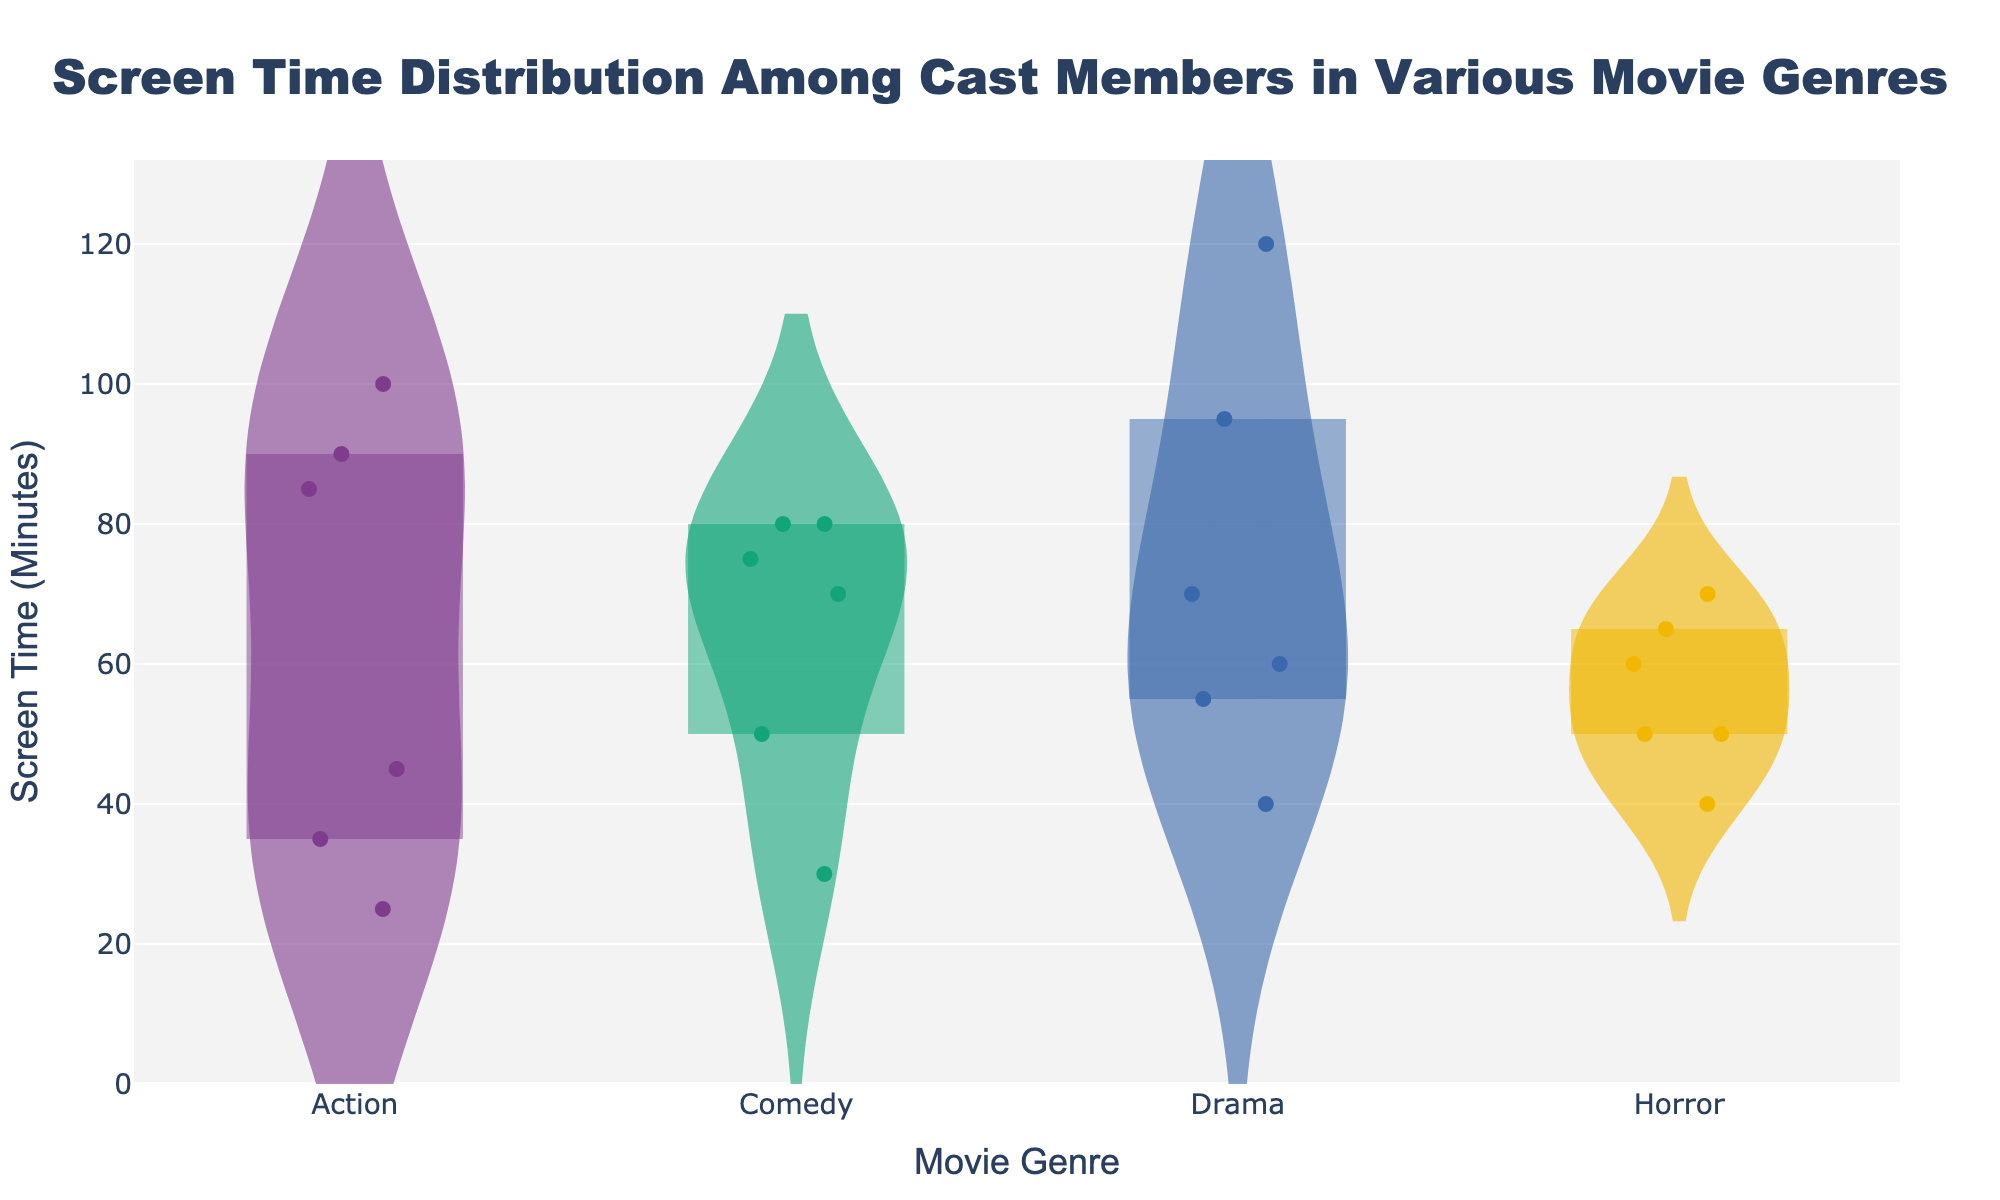What is the title of the chart? The title of the chart is displayed at the top and it reads “Screen Time Distribution Among Cast Members in Various Movie Genres.”
Answer: Screen Time Distribution Among Cast Members in Various Movie Genres What are the movie genres shown on the x-axis? The x-axis labels represent different movie genres shown, which include Action, Comedy, Drama, and Horror.
Answer: Action, Comedy, Drama, Horror Which genre has the actor with the highest screen time? By examining the highest points in each violin plot, Drama has the actor with the highest screen time, where Leonardo DiCaprio in "Wolf of Wall Street" has 120 minutes.
Answer: Drama What is the range of screen times in the Comedy genre? In the violin plot for Comedy, the screen times range from the minimum visible point (30 minutes for Richard Jenkins) to the maximum visible point (80 minutes for Will Ferrell and John C. Reilly).
Answer: 30 to 80 minutes Which genre shows the most variability in screen time among its cast members? The most variability can be inferred from the width and spread of the violin plot. Drama demonstrates a wide spread of screen times from 40 to 120 minutes, indicating the most variability.
Answer: Drama What is the median screen time for actors in the Action genre? The median is indicated by the horizontal line inside the box plot overlaid on the violin plot. For Action, the median screen time is around 45 minutes.
Answer: 45 minutes How many actors had exactly 80 minutes of screen time in the Comedy genre? By observing the jittered points within the Comedy genre, two actors (Will Ferrell and John C. Reilly) had exactly 80 minutes of screen time.
Answer: 2 actors Between Action and Horror genres, which one has a higher median screen time? By comparing the median lines in the Action and Horror violin plots, Action’s median (45 minutes) is lower compared to Horror’s median (approximately 60 minutes).
Answer: Horror Among all genres, which one has the lowest median screen time? The lowest median screen time can be identified by comparing the median lines in each violin plot. Comedy has the lowest median screen time at around 50 minutes.
Answer: Comedy 